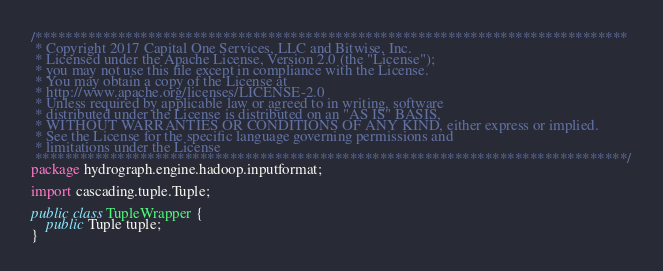Convert code to text. <code><loc_0><loc_0><loc_500><loc_500><_Java_>/*******************************************************************************
 * Copyright 2017 Capital One Services, LLC and Bitwise, Inc.
 * Licensed under the Apache License, Version 2.0 (the "License");
 * you may not use this file except in compliance with the License.
 * You may obtain a copy of the License at
 * http://www.apache.org/licenses/LICENSE-2.0
 * Unless required by applicable law or agreed to in writing, software
 * distributed under the License is distributed on an "AS IS" BASIS,
 * WITHOUT WARRANTIES OR CONDITIONS OF ANY KIND, either express or implied.
 * See the License for the specific language governing permissions and
 * limitations under the License
 *******************************************************************************/
package hydrograph.engine.hadoop.inputformat;

import cascading.tuple.Tuple;

public class TupleWrapper {
    public Tuple tuple;
}</code> 